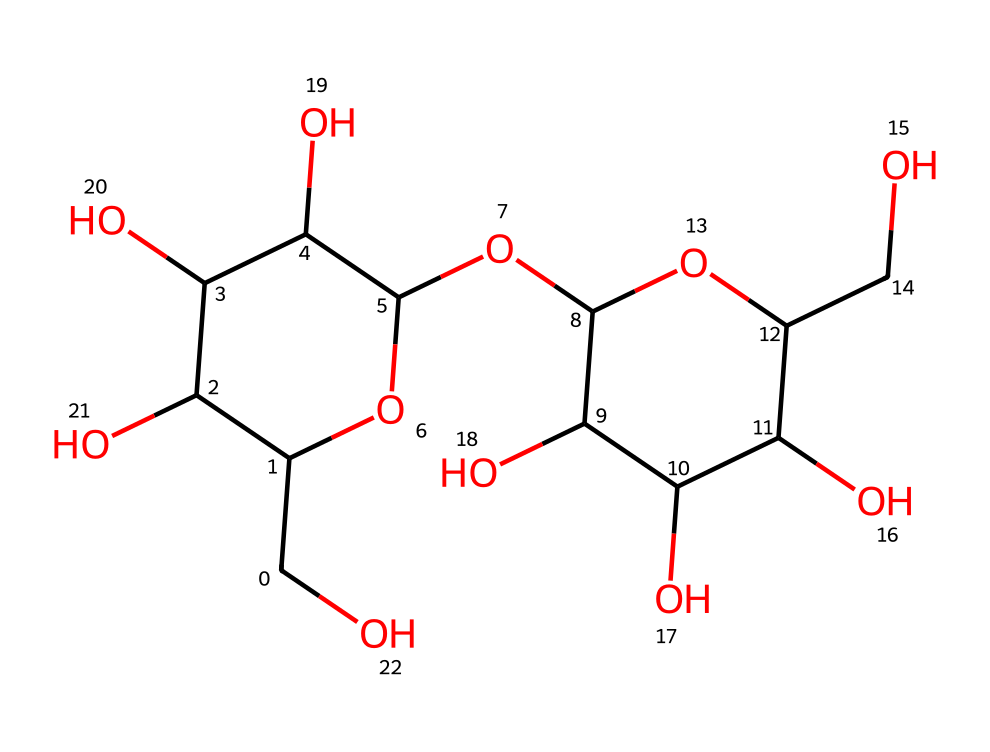What is the molecular formula of lactose? The molecular structure contains the atoms Carbon, Hydrogen, and Oxygen. By counting the individual atoms in the SMILES representation, we find the total count leads to a molecular formula of C12H22O11.
Answer: C12H22O11 How many carbon atoms are in lactose? In the given SMILES representation, I count the number of Carbon ('C') characters. There are 12 Carbon atoms in the structure.
Answer: 12 Is lactose a disaccharide? The structure of lactose consists of two monosaccharide units bonded together; specifically, it is formed from galactose and glucose, which identifies it as a disaccharide.
Answer: Yes What type of glycosidic bond is present in lactose? The bond linking the two monosaccharides in lactose is a beta-1,4-glycosidic bond, which is formed between the hydroxyl groups of the two sugar units.
Answer: beta-1,4 What is the functional group responsible for the sweetness of lactose? The sweetness in lactose is attributed to the presence of hydroxyl (-OH) groups which contribute to its ability to bind to sweetness receptors.
Answer: hydroxyl Does lactose exhibit reducing properties? Yes, lactose has a free anomeric carbon in its structure which allows it to act as a reducing sugar, capable of donating electrons.
Answer: Yes 